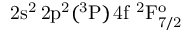Convert formula to latex. <formula><loc_0><loc_0><loc_500><loc_500>2 s ^ { 2 } \, 2 p ^ { 2 } ( ^ { 3 } P ) \, 4 f ^ { 2 } F _ { 7 / 2 } ^ { o }</formula> 